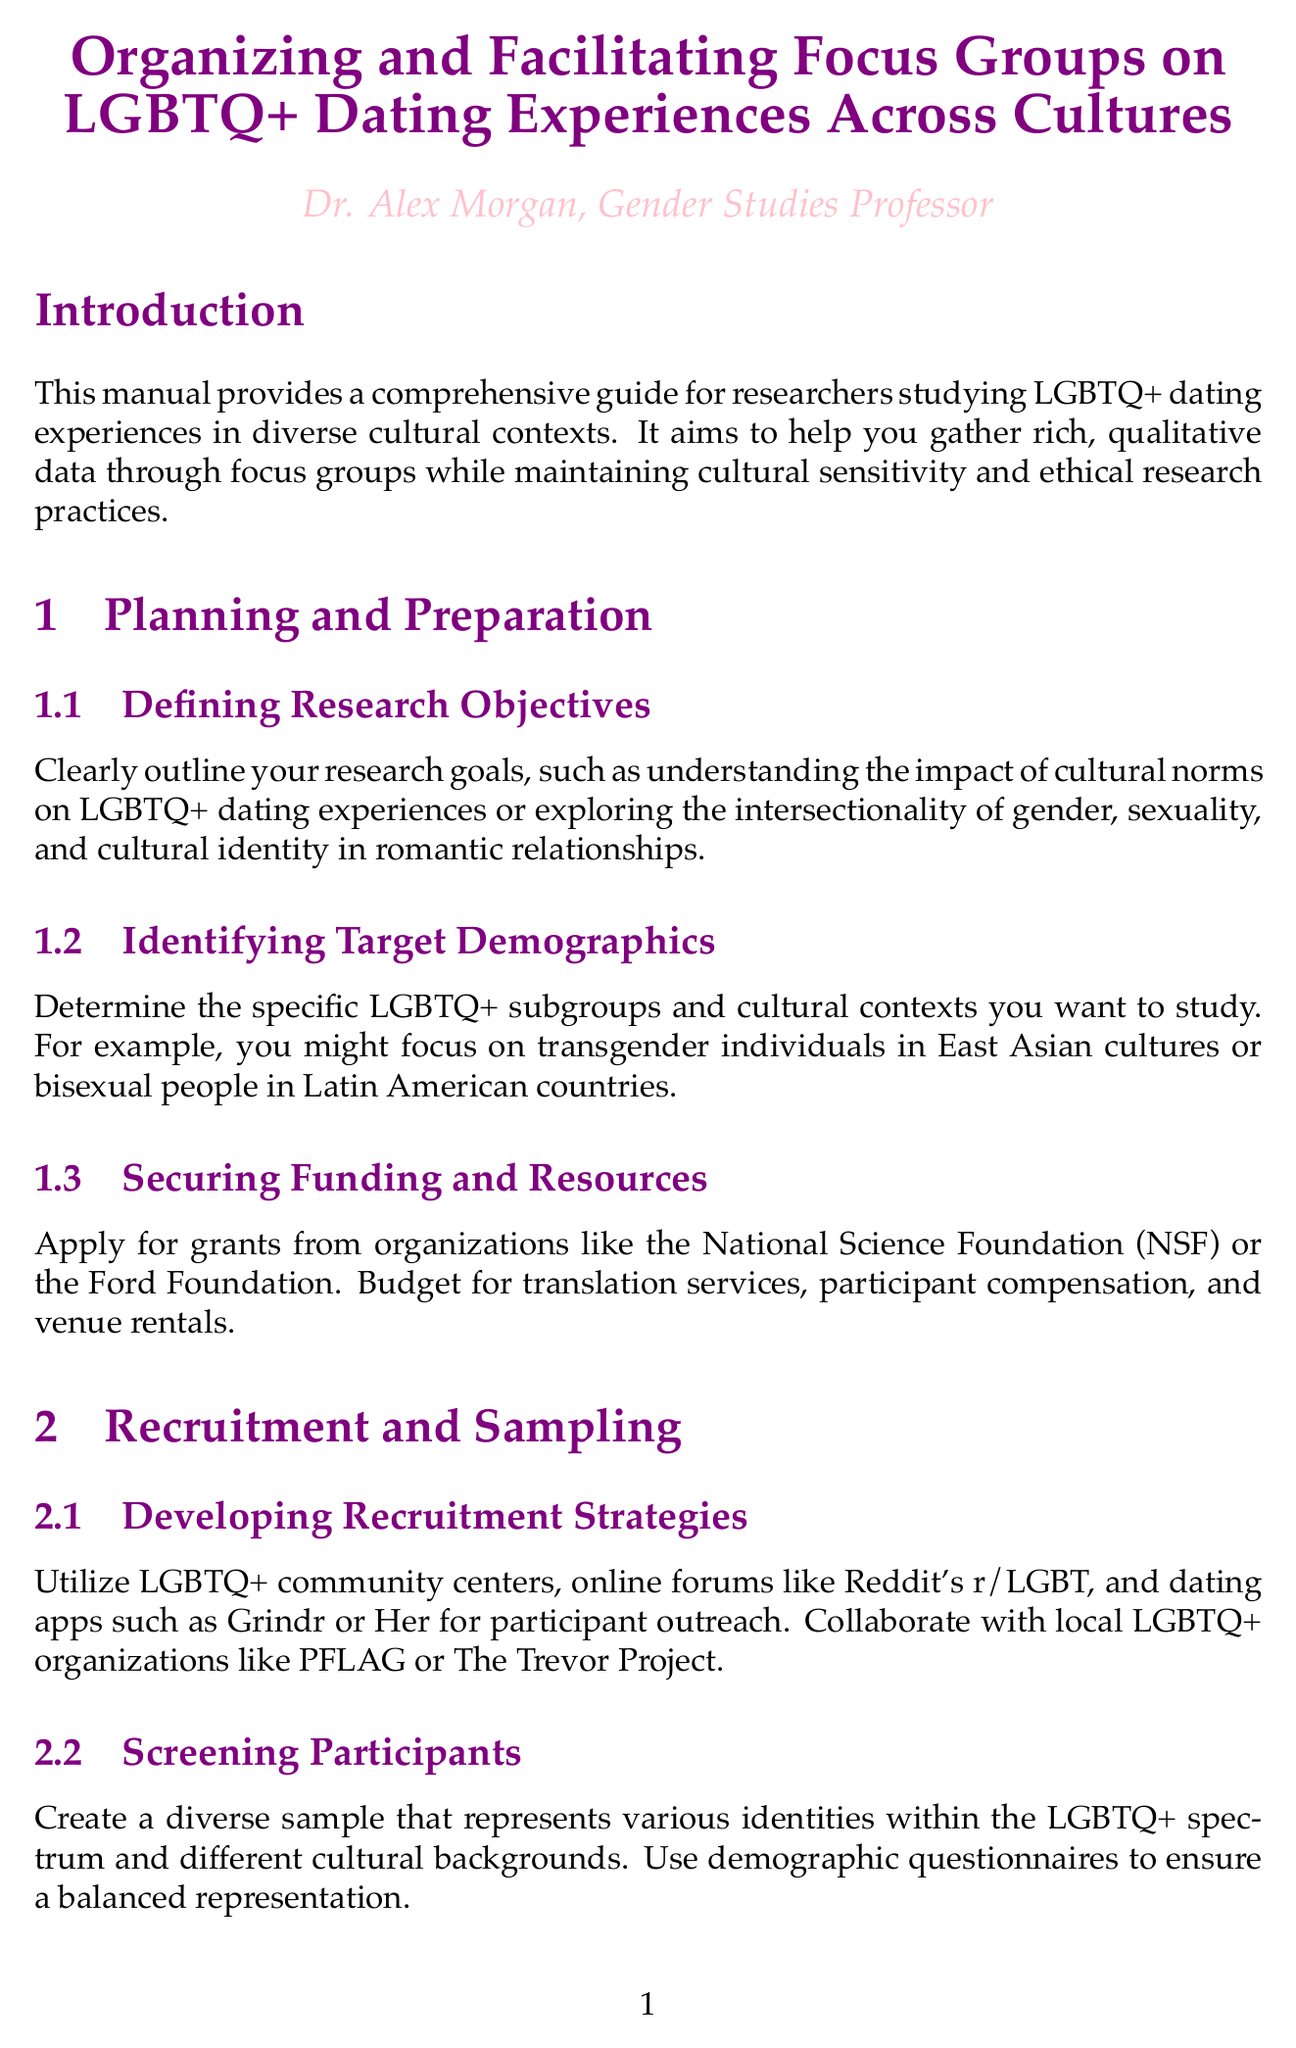what is the title of the manual? The title of the manual as mentioned in the document is explicitly stated at the beginning.
Answer: Organizing and Facilitating Focus Groups on LGBTQ+ Dating Experiences Across Cultures who is the author of the manual? The document provides the name of the individual responsible for the manual.
Answer: Dr. Alex Morgan what is one of the research objectives mentioned? The document lists specific research objectives in the context of LGBTQ+ dating experiences that researchers should outline.
Answer: Understanding the impact of cultural norms on LGBTQ+ dating experiences which section covers recruitment strategies? The section titled in the document that focuses on how to recruit participants for the focus groups.
Answer: Recruitment and Sampling name one organization suggested for obtaining funding. The document mentions specific organizations that researchers can apply to for funding.
Answer: National Science Foundation what software is recommended for coding and thematic analysis? The manual indicates qualitative data analysis software suitable for analyzing data.
Answer: NVivo how does the manual suggest setting the tone in focus groups? The document includes a subsection that discusses creating welcoming environments during focus group facilitation.
Answer: Using inclusive language what is a key ethical consideration listed? The document emphasizes various ethical considerations that should be kept in mind when conducting research.
Answer: Ensuring participant safety 